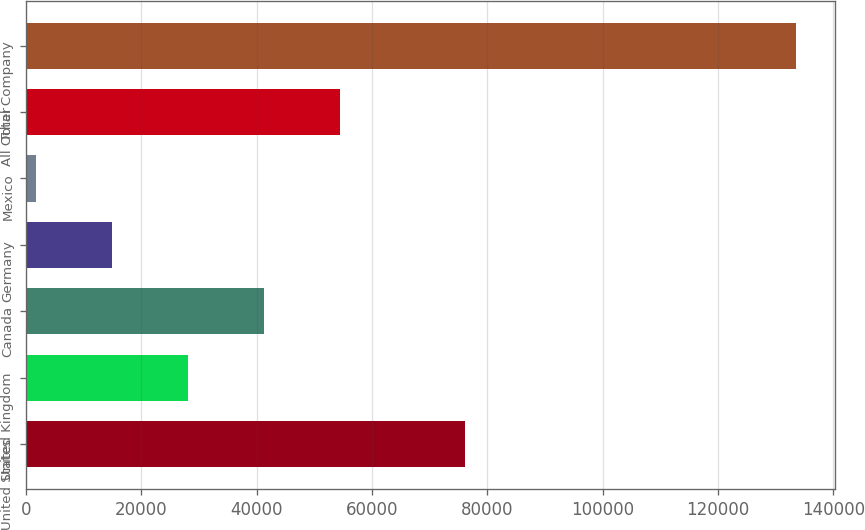Convert chart to OTSL. <chart><loc_0><loc_0><loc_500><loc_500><bar_chart><fcel>United States<fcel>United Kingdom<fcel>Canada<fcel>Germany<fcel>Mexico<fcel>All Other<fcel>Total Company<nl><fcel>76055<fcel>28166.2<fcel>41340.3<fcel>14992.1<fcel>1818<fcel>54514.4<fcel>133559<nl></chart> 